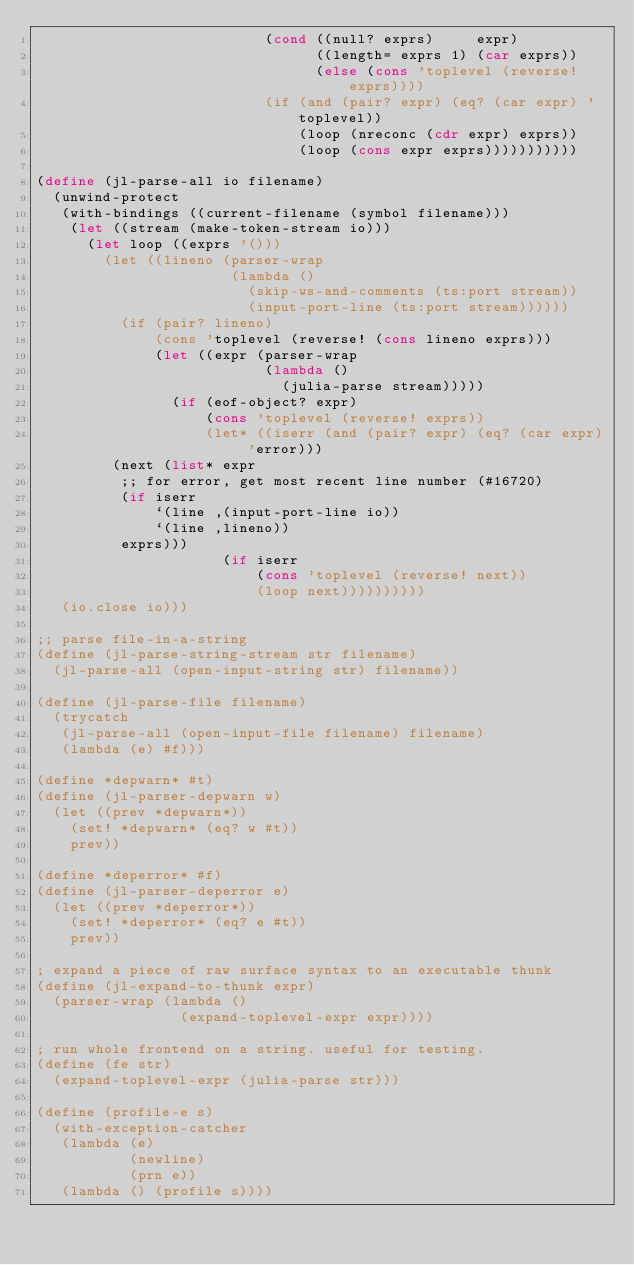Convert code to text. <code><loc_0><loc_0><loc_500><loc_500><_Scheme_>                           (cond ((null? exprs)     expr)
                                 ((length= exprs 1) (car exprs))
                                 (else (cons 'toplevel (reverse! exprs))))
                           (if (and (pair? expr) (eq? (car expr) 'toplevel))
                               (loop (nreconc (cdr expr) exprs))
                               (loop (cons expr exprs)))))))))))

(define (jl-parse-all io filename)
  (unwind-protect
   (with-bindings ((current-filename (symbol filename)))
    (let ((stream (make-token-stream io)))
      (let loop ((exprs '()))
        (let ((lineno (parser-wrap
                       (lambda ()
                         (skip-ws-and-comments (ts:port stream))
                         (input-port-line (ts:port stream))))))
          (if (pair? lineno)
              (cons 'toplevel (reverse! (cons lineno exprs)))
              (let ((expr (parser-wrap
                           (lambda ()
                             (julia-parse stream)))))
                (if (eof-object? expr)
                    (cons 'toplevel (reverse! exprs))
                    (let* ((iserr (and (pair? expr) (eq? (car expr) 'error)))
			   (next (list* expr
					;; for error, get most recent line number (#16720)
					(if iserr
					    `(line ,(input-port-line io))
					    `(line ,lineno))
					exprs)))
                      (if iserr
                          (cons 'toplevel (reverse! next))
                          (loop next))))))))))
   (io.close io)))

;; parse file-in-a-string
(define (jl-parse-string-stream str filename)
  (jl-parse-all (open-input-string str) filename))

(define (jl-parse-file filename)
  (trycatch
   (jl-parse-all (open-input-file filename) filename)
   (lambda (e) #f)))

(define *depwarn* #t)
(define (jl-parser-depwarn w)
  (let ((prev *depwarn*))
    (set! *depwarn* (eq? w #t))
    prev))

(define *deperror* #f)
(define (jl-parser-deperror e)
  (let ((prev *deperror*))
    (set! *deperror* (eq? e #t))
    prev))

; expand a piece of raw surface syntax to an executable thunk
(define (jl-expand-to-thunk expr)
  (parser-wrap (lambda ()
                 (expand-toplevel-expr expr))))

; run whole frontend on a string. useful for testing.
(define (fe str)
  (expand-toplevel-expr (julia-parse str)))

(define (profile-e s)
  (with-exception-catcher
   (lambda (e)
           (newline)
           (prn e))
   (lambda () (profile s))))
</code> 